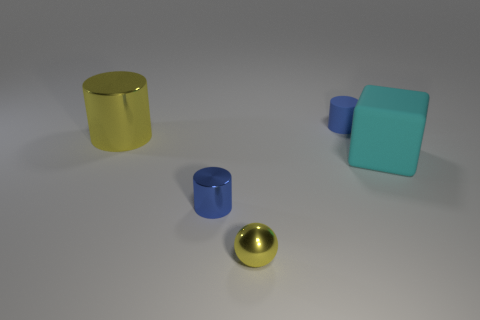Add 4 big shiny cylinders. How many objects exist? 9 Subtract all cyan spheres. Subtract all blue cylinders. How many spheres are left? 1 Subtract all spheres. How many objects are left? 4 Subtract 0 blue spheres. How many objects are left? 5 Subtract all big cubes. Subtract all shiny things. How many objects are left? 1 Add 3 rubber cubes. How many rubber cubes are left? 4 Add 5 purple shiny blocks. How many purple shiny blocks exist? 5 